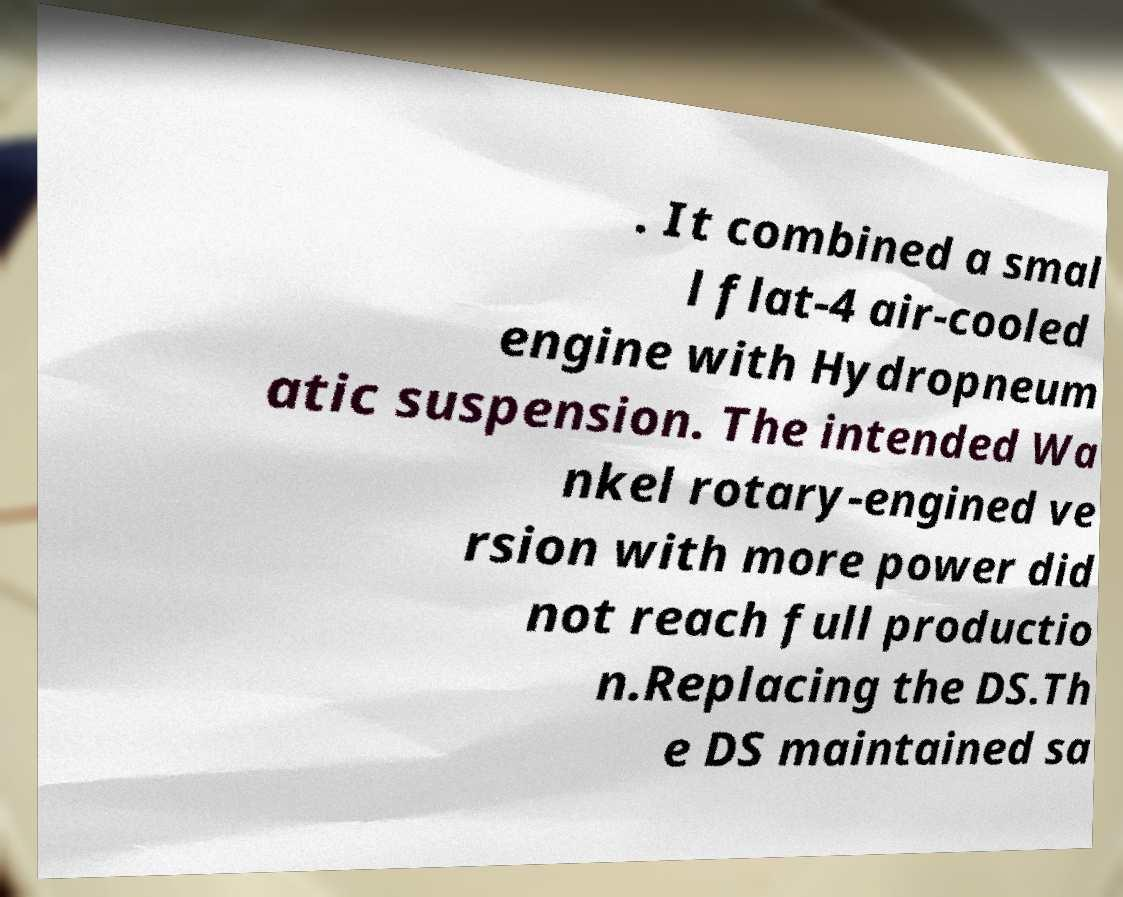Could you assist in decoding the text presented in this image and type it out clearly? . It combined a smal l flat-4 air-cooled engine with Hydropneum atic suspension. The intended Wa nkel rotary-engined ve rsion with more power did not reach full productio n.Replacing the DS.Th e DS maintained sa 